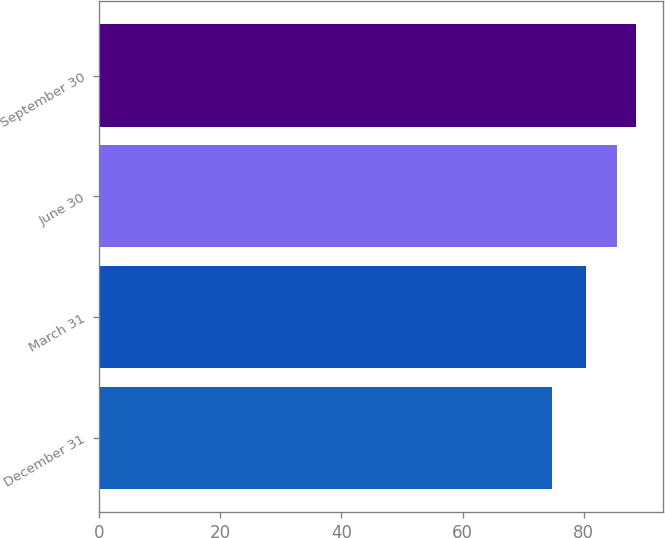Convert chart to OTSL. <chart><loc_0><loc_0><loc_500><loc_500><bar_chart><fcel>December 31<fcel>March 31<fcel>June 30<fcel>September 30<nl><fcel>74.73<fcel>80.4<fcel>85.54<fcel>88.69<nl></chart> 